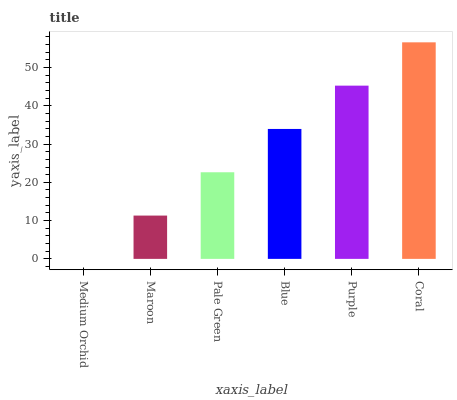Is Medium Orchid the minimum?
Answer yes or no. Yes. Is Coral the maximum?
Answer yes or no. Yes. Is Maroon the minimum?
Answer yes or no. No. Is Maroon the maximum?
Answer yes or no. No. Is Maroon greater than Medium Orchid?
Answer yes or no. Yes. Is Medium Orchid less than Maroon?
Answer yes or no. Yes. Is Medium Orchid greater than Maroon?
Answer yes or no. No. Is Maroon less than Medium Orchid?
Answer yes or no. No. Is Blue the high median?
Answer yes or no. Yes. Is Pale Green the low median?
Answer yes or no. Yes. Is Pale Green the high median?
Answer yes or no. No. Is Purple the low median?
Answer yes or no. No. 